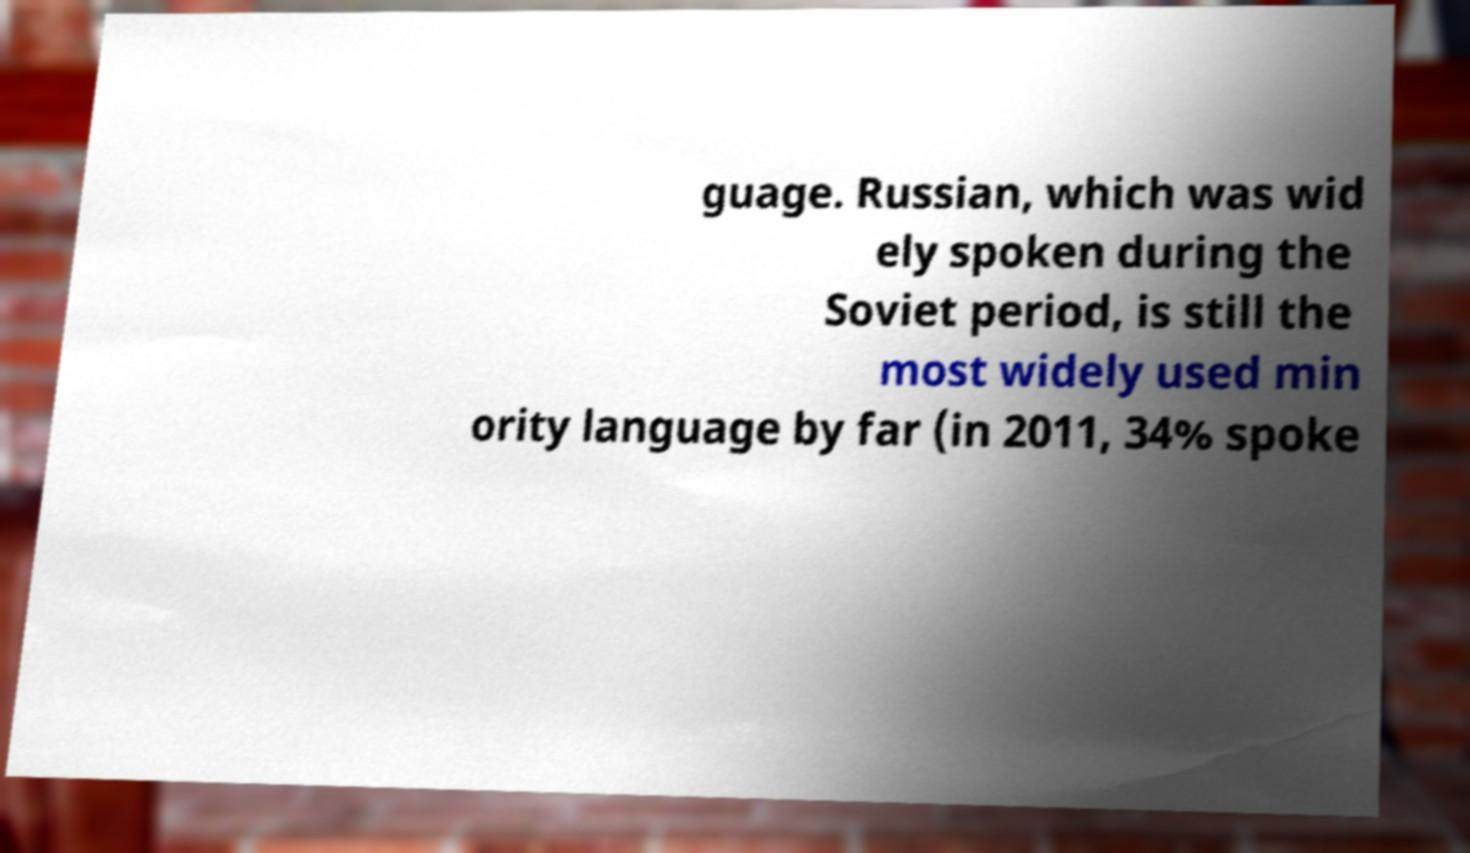For documentation purposes, I need the text within this image transcribed. Could you provide that? guage. Russian, which was wid ely spoken during the Soviet period, is still the most widely used min ority language by far (in 2011, 34% spoke 